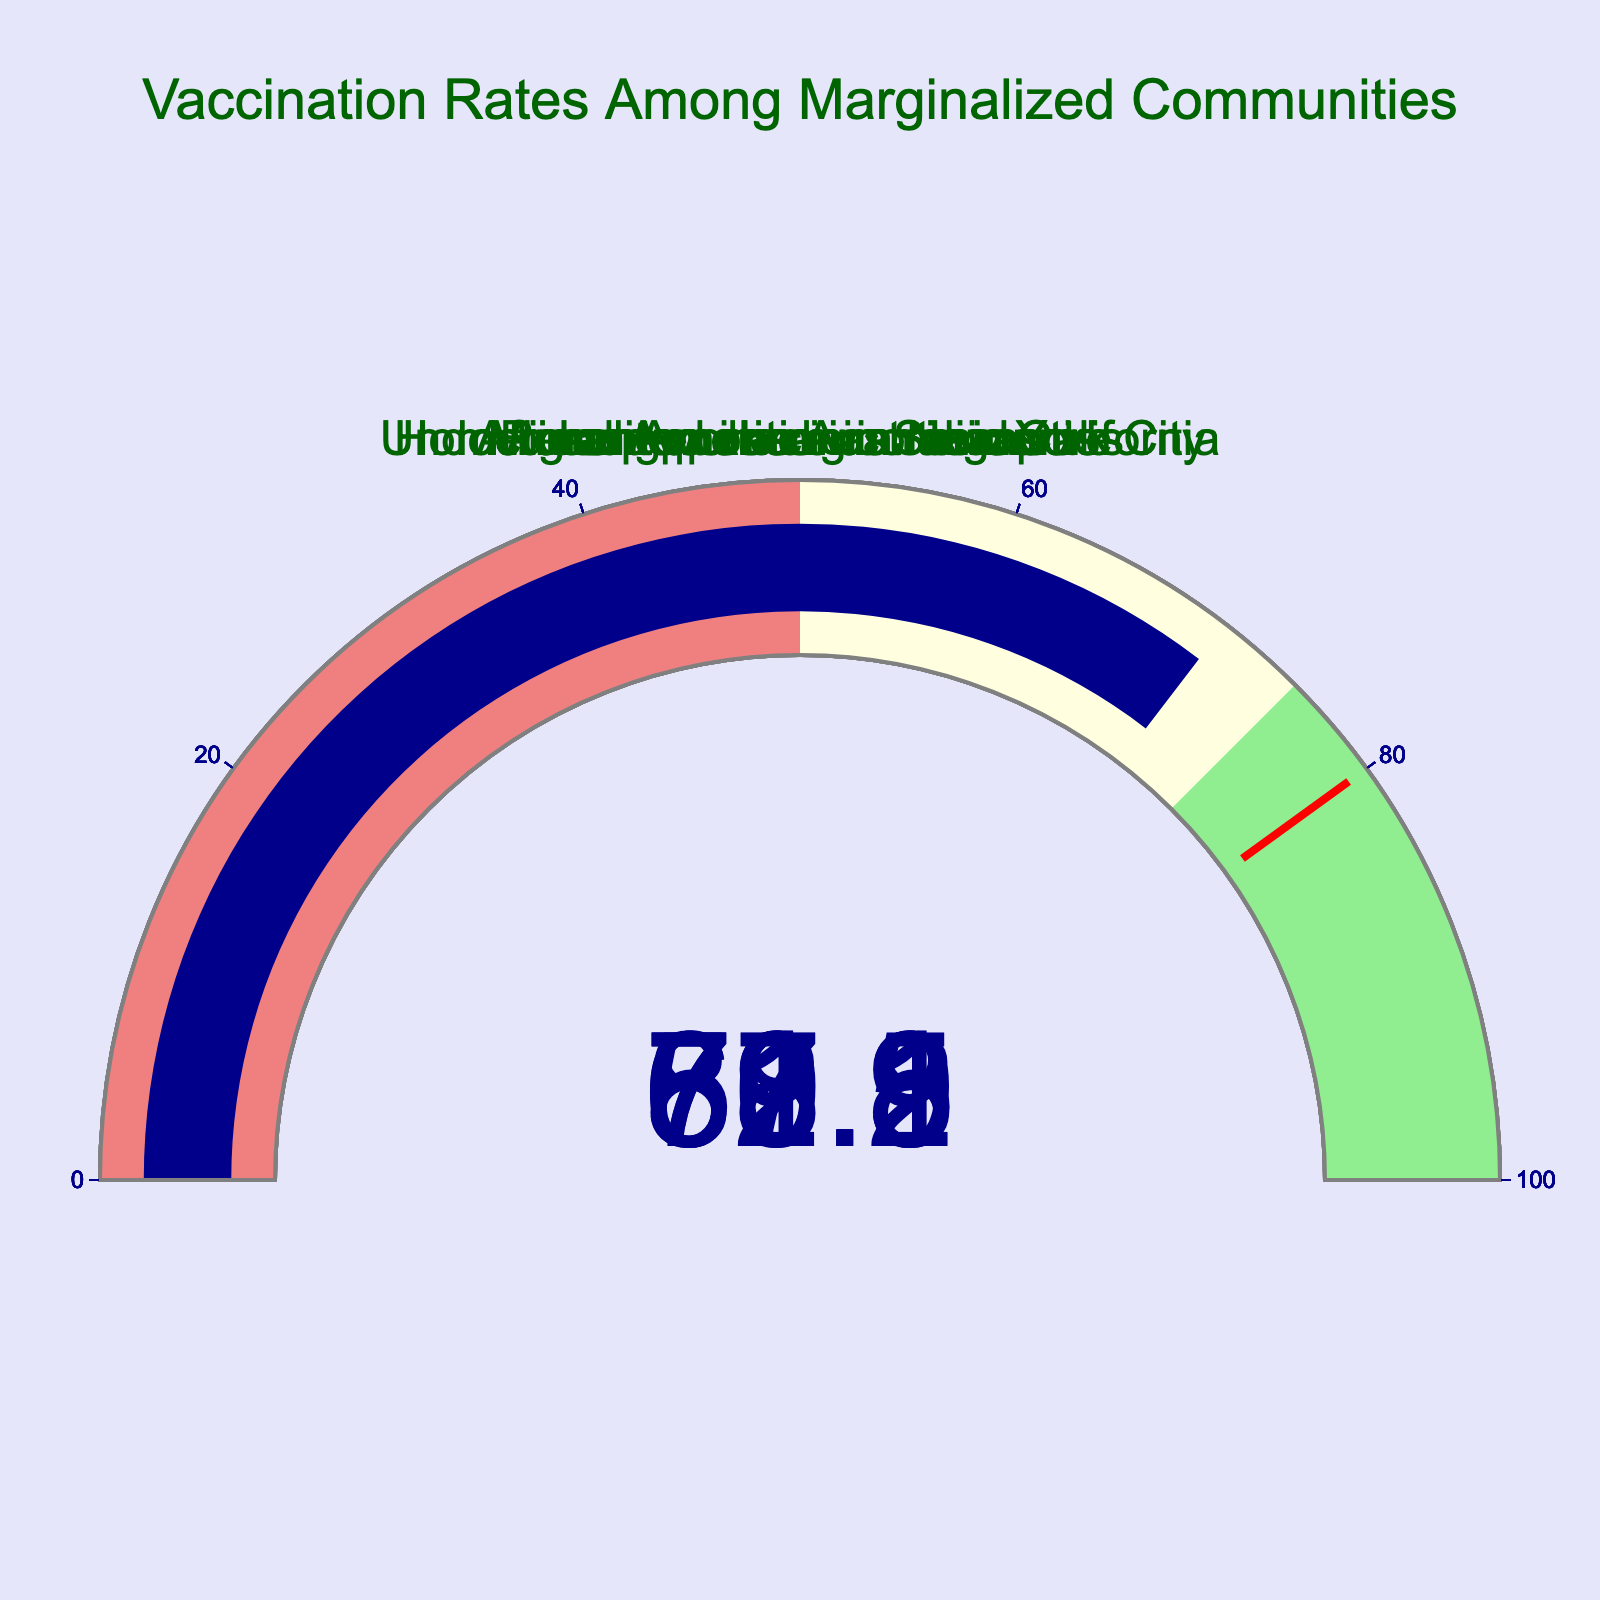What is the vaccination rate for the Indigenous Australians? The vaccination rate value for the Indigenous Australians can be found in the figure.
Answer: 67.3 How many communities have a vaccination rate above 70%? By checking each gauge on the chart, we observe that four communities have a vaccination rate above 70%: African American communities, Migrant workers in Singapore, Rural Appalachian residents, and Aboriginal Australians.
Answer: 4 Which community has the lowest vaccination rate? By comparing the values on each gauge, it is clear that the Homeless population in New York City has the lowest vaccination rate at 58.9.
Answer: Homeless population in New York City Is the vaccination rate of the Migrant workers in Singapore greater than the threshold value of 80? The threshold value on the gauge is 80. The vaccination rate for Migrant workers in Singapore is shown to be 89.1, which is greater than 80.
Answer: Yes What is the difference in vaccination rates between the Rural Appalachian residents and the Homeless population in New York City? To find the difference, subtract the vaccination rate of the Homeless population in New York City (58.9) from that of the Rural Appalachian residents (70.8).
Answer: 11.9 What is the average vaccination rate for all the communities displayed in the figure? Add all the vaccination rates together (67.3 + 72.5 + 89.1 + 58.9 + 61.2 + 70.8) and divide by the number of communities (6). The total is 419.8, and the average is 419.8 / 6.
Answer: 69.97 Which communities have a vaccination rate between 60% and 75%? By observing the gauge chart, the communities with vaccination rates between 60% and 75% are Indigenous Australians, African American communities, Undocumented immigrants in California, and Rural Appalachian residents.
Answer: Indigenous Australians, African American communities, Undocumented immigrants in California, Rural Appalachian residents How does the vaccination rate of African American communities compare with that of Migrant workers in Singapore? By comparing the gauge values, the African American communities have a vaccination rate of 72.5, which is lower than the 89.1 of the Migrant workers in Singapore.
Answer: Lower Which community's vaccination rate is closest to the threshold value of 80? By reviewing the gauges, the closest vaccination rate to the threshold value of 80 is the Migrant workers in Singapore at 89.1.
Answer: Migrant workers in Singapore What's the sum of the vaccination rates of Indigenous Australians and Undocumented immigrants in California? By adding the vaccination rates of Indigenous Australians (67.3) and Undocumented immigrants in California (61.2), we get 67.3 + 61.2.
Answer: 128.5 